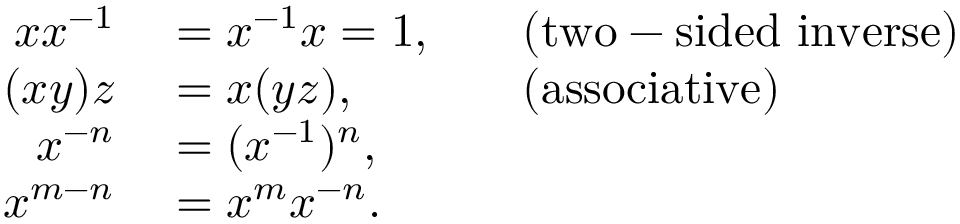<formula> <loc_0><loc_0><loc_500><loc_500>\begin{array} { r l r l } { x x ^ { - 1 } } & = x ^ { - 1 } x = 1 , } & { ( t w o - s i d e d i n v e r s e ) } } \\ { ( x y ) z } & = x ( y z ) , } & { ( a s s o c i a t i v e ) } } \\ { x ^ { - n } } & = ( x ^ { - 1 } ) ^ { n } , } \\ { x ^ { m - n } } & = x ^ { m } x ^ { - n } . } \end{array}</formula> 